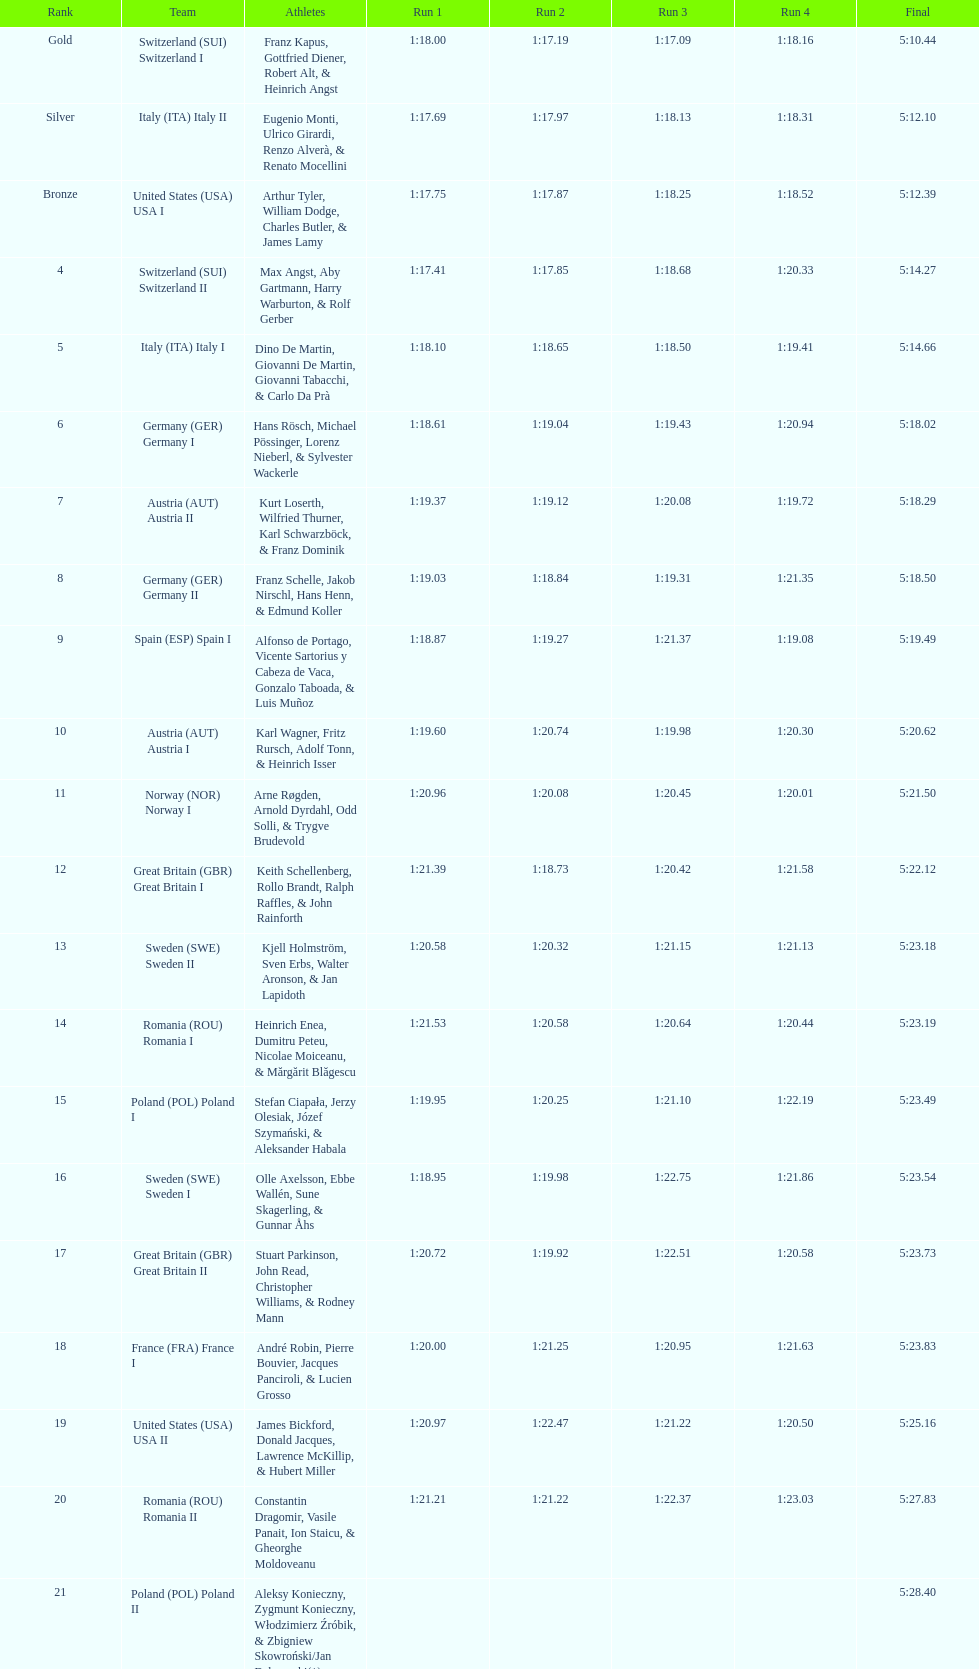What is the combined total of runs? 4. 